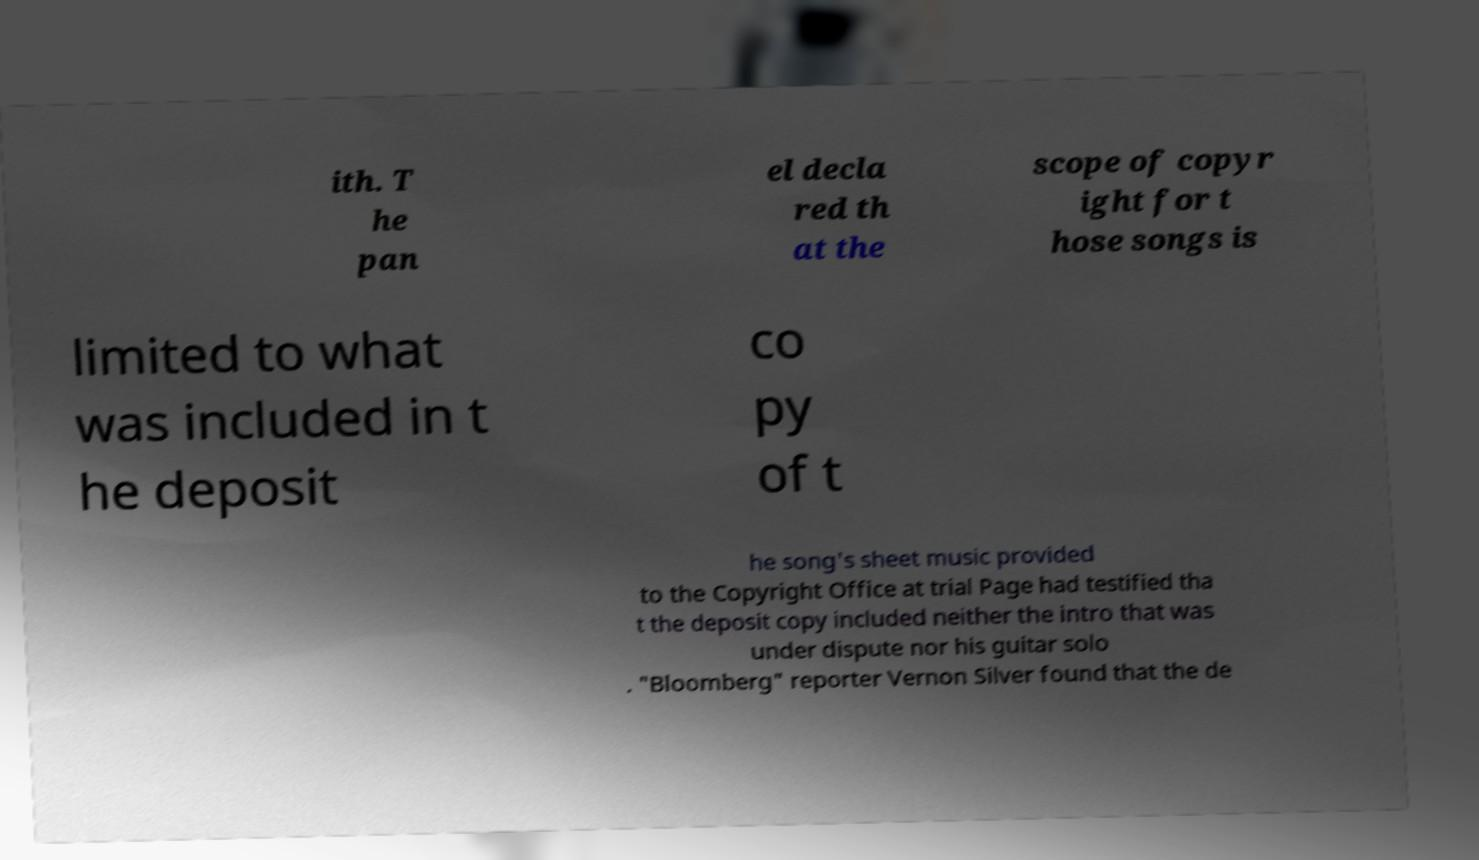I need the written content from this picture converted into text. Can you do that? ith. T he pan el decla red th at the scope of copyr ight for t hose songs is limited to what was included in t he deposit co py of t he song's sheet music provided to the Copyright Office at trial Page had testified tha t the deposit copy included neither the intro that was under dispute nor his guitar solo . "Bloomberg" reporter Vernon Silver found that the de 